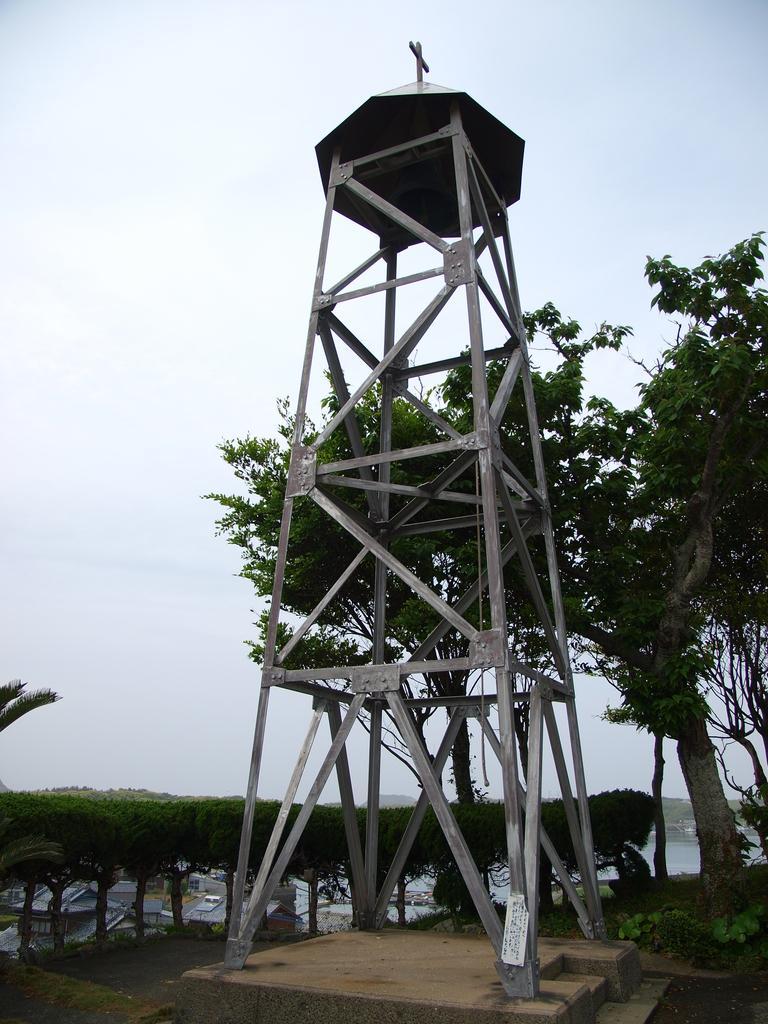In one or two sentences, can you explain what this image depicts? In this image we can see a metal tower placed on the wooden surface and we can also see trees and sky. 